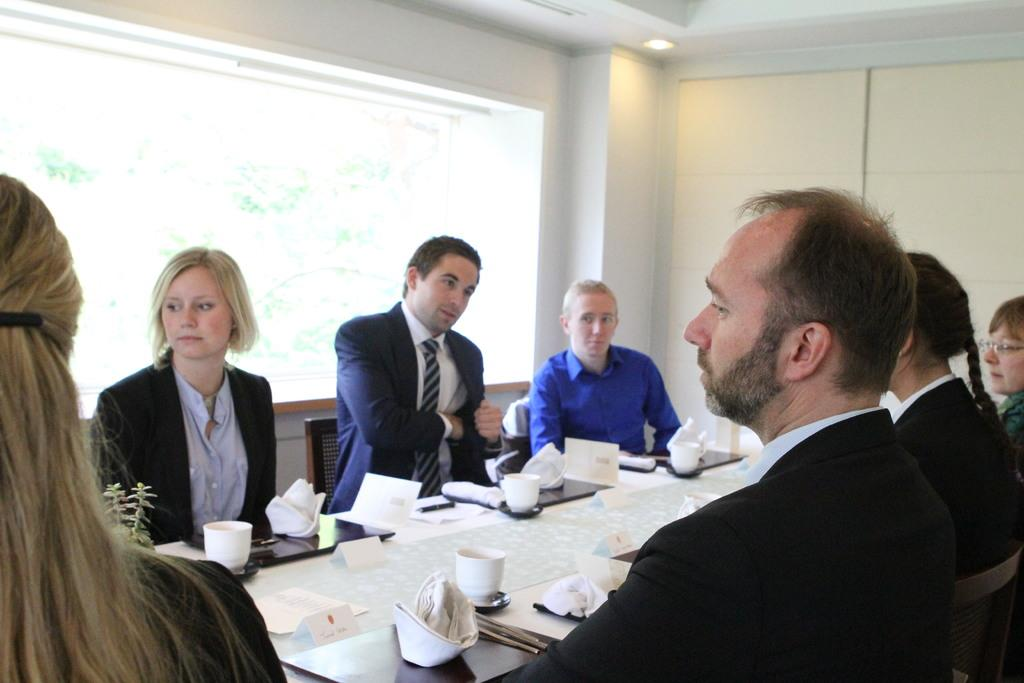What are the people in the image doing? The people in the image are sitting on chairs. What is in front of the people? There is a table in front of the people. What items can be seen on the table? There are files and cups on the table. What type of riddle is being solved by the people in the image? There is no riddle present in the image; the people are simply sitting on chairs with a table in front of them. 